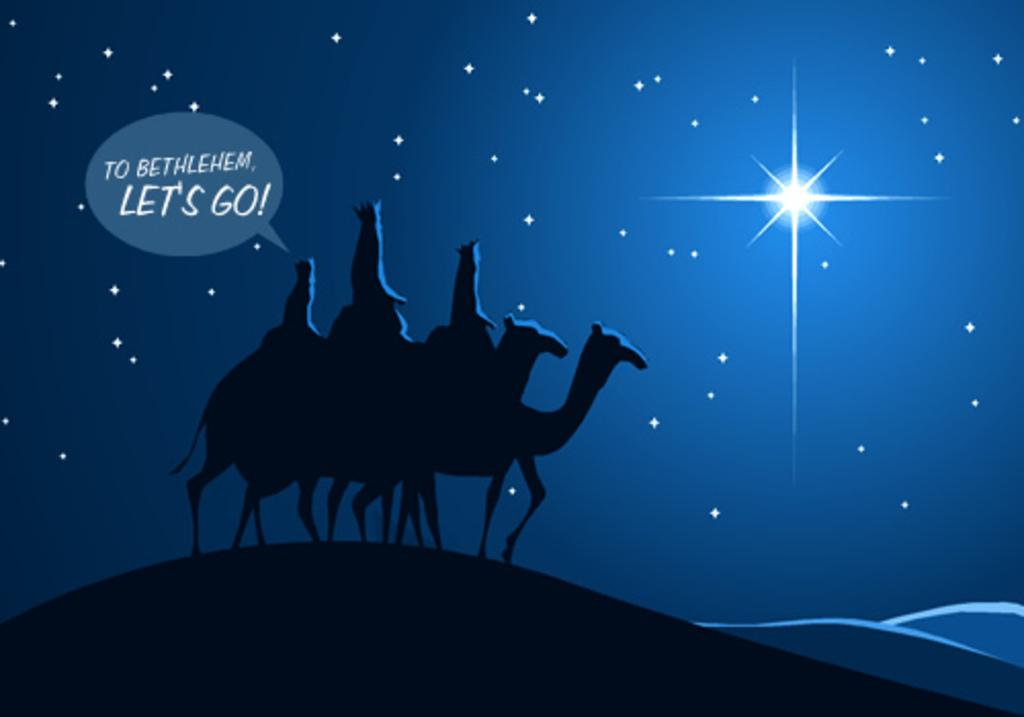What type of image is depicted in the picture? There is a graphical image in the picture. What animals can be seen on the ground in the image? There are camels on the ground in the image. What celestial objects are visible in the background of the image? Stars are visible in the sky in the background of the image. Where is the text located in the image? The text is on the left side of the image. Can you see any magic happening in the image? There is no magic present in the image. Are there any fingers visible in the image? There is no mention of fingers in the provided facts, and therefore we cannot determine if any are visible in the image. 